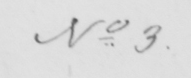Please provide the text content of this handwritten line. No . 3 . 